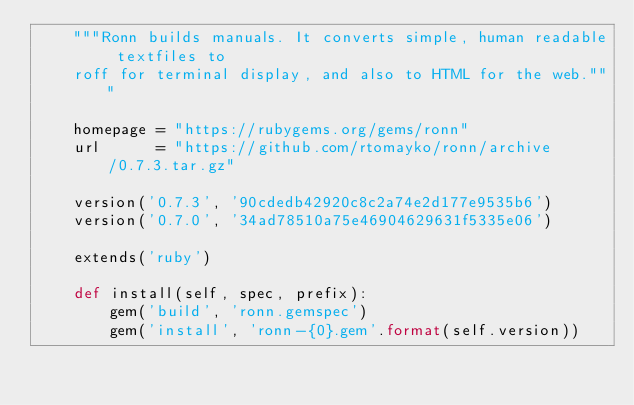Convert code to text. <code><loc_0><loc_0><loc_500><loc_500><_Python_>    """Ronn builds manuals. It converts simple, human readable textfiles to
    roff for terminal display, and also to HTML for the web."""

    homepage = "https://rubygems.org/gems/ronn"
    url      = "https://github.com/rtomayko/ronn/archive/0.7.3.tar.gz"

    version('0.7.3', '90cdedb42920c8c2a74e2d177e9535b6')
    version('0.7.0', '34ad78510a75e46904629631f5335e06')

    extends('ruby')

    def install(self, spec, prefix):
        gem('build', 'ronn.gemspec')
        gem('install', 'ronn-{0}.gem'.format(self.version))
</code> 